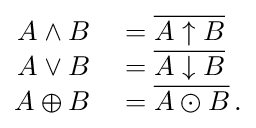<formula> <loc_0><loc_0><loc_500><loc_500>\begin{array} { r l } { A \wedge B } & = \overline { A \uparrow B } } \\ { A \vee B } & = \overline { A \downarrow B } } \\ { A \oplus B } & = \overline { A \odot B } \, . } \end{array}</formula> 